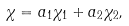Convert formula to latex. <formula><loc_0><loc_0><loc_500><loc_500>\chi = a _ { 1 } \chi _ { 1 } + a _ { 2 } \chi _ { 2 } ,</formula> 